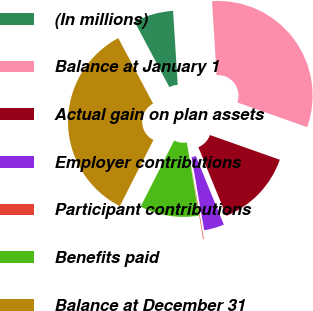Convert chart to OTSL. <chart><loc_0><loc_0><loc_500><loc_500><pie_chart><fcel>(In millions)<fcel>Balance at January 1<fcel>Actual gain on plan assets<fcel>Employer contributions<fcel>Participant contributions<fcel>Benefits paid<fcel>Balance at December 31<nl><fcel>6.77%<fcel>31.42%<fcel>13.42%<fcel>3.44%<fcel>0.12%<fcel>10.09%<fcel>34.75%<nl></chart> 